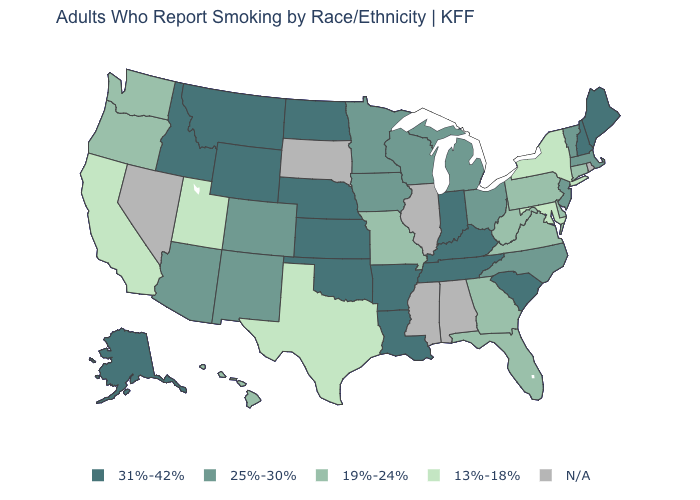Name the states that have a value in the range 25%-30%?
Quick response, please. Arizona, Colorado, Iowa, Massachusetts, Michigan, Minnesota, New Jersey, New Mexico, North Carolina, Ohio, Vermont, Wisconsin. What is the value of South Carolina?
Concise answer only. 31%-42%. Which states have the lowest value in the USA?
Concise answer only. California, Maryland, New York, Texas, Utah. What is the lowest value in the USA?
Be succinct. 13%-18%. What is the value of South Carolina?
Keep it brief. 31%-42%. Name the states that have a value in the range 25%-30%?
Give a very brief answer. Arizona, Colorado, Iowa, Massachusetts, Michigan, Minnesota, New Jersey, New Mexico, North Carolina, Ohio, Vermont, Wisconsin. What is the value of Alabama?
Be succinct. N/A. Which states have the lowest value in the West?
Concise answer only. California, Utah. What is the value of Indiana?
Answer briefly. 31%-42%. Which states have the lowest value in the South?
Concise answer only. Maryland, Texas. Among the states that border New York , which have the highest value?
Give a very brief answer. Massachusetts, New Jersey, Vermont. Does New Hampshire have the highest value in the Northeast?
Write a very short answer. Yes. What is the value of Montana?
Keep it brief. 31%-42%. Among the states that border Kansas , does Nebraska have the highest value?
Quick response, please. Yes. 